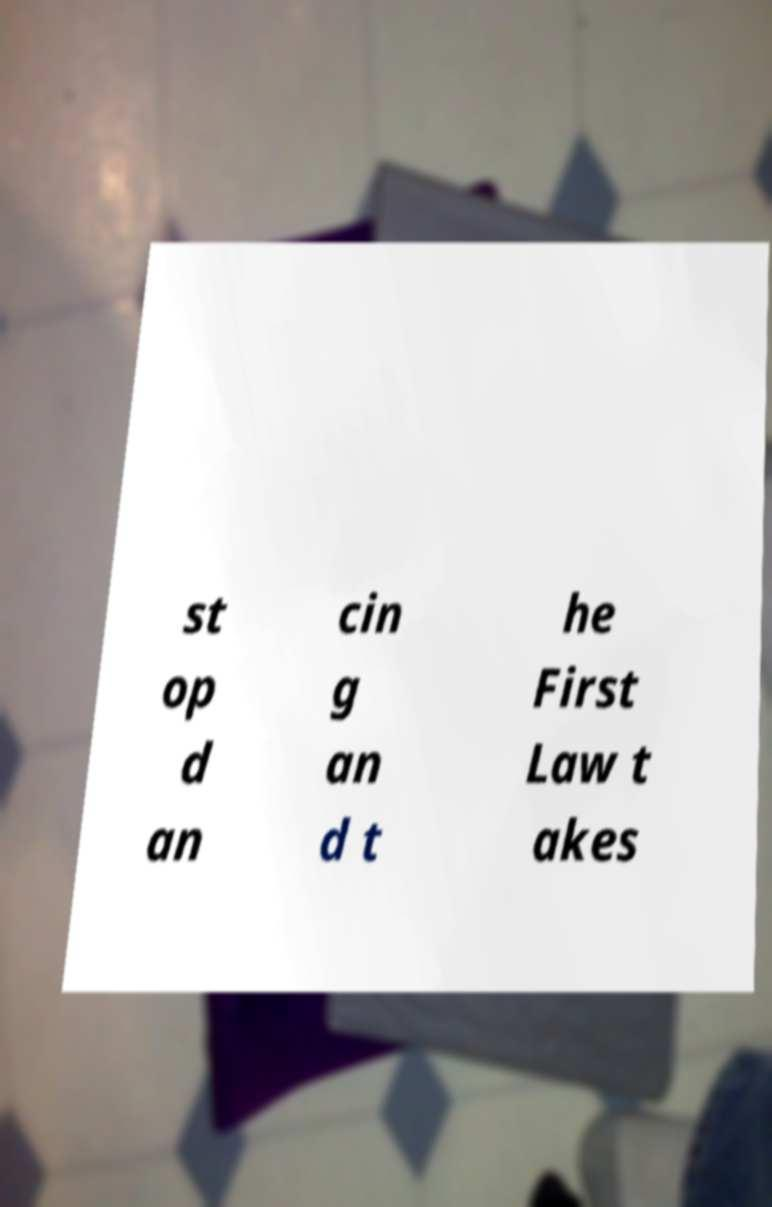There's text embedded in this image that I need extracted. Can you transcribe it verbatim? st op d an cin g an d t he First Law t akes 